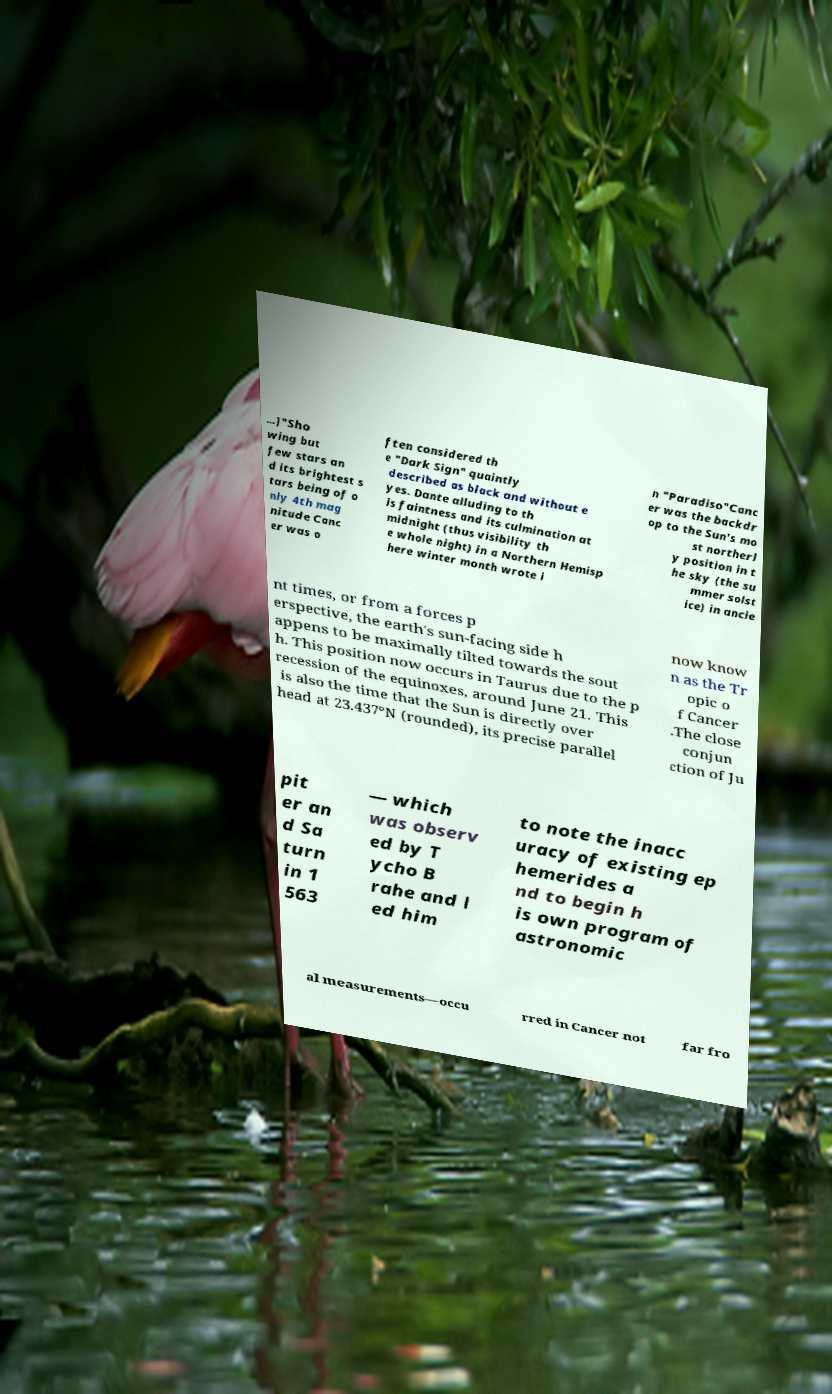Could you extract and type out the text from this image? ...]"Sho wing but few stars an d its brightest s tars being of o nly 4th mag nitude Canc er was o ften considered th e "Dark Sign" quaintly described as black and without e yes. Dante alluding to th is faintness and its culmination at midnight (thus visibility th e whole night) in a Northern Hemisp here winter month wrote i n "Paradiso"Canc er was the backdr op to the Sun's mo st northerl y position in t he sky (the su mmer solst ice) in ancie nt times, or from a forces p erspective, the earth's sun-facing side h appens to be maximally tilted towards the sout h. This position now occurs in Taurus due to the p recession of the equinoxes, around June 21. This is also the time that the Sun is directly over head at 23.437°N (rounded), its precise parallel now know n as the Tr opic o f Cancer .The close conjun ction of Ju pit er an d Sa turn in 1 563 — which was observ ed by T ycho B rahe and l ed him to note the inacc uracy of existing ep hemerides a nd to begin h is own program of astronomic al measurements—occu rred in Cancer not far fro 